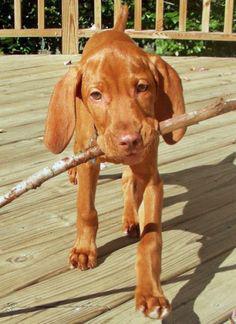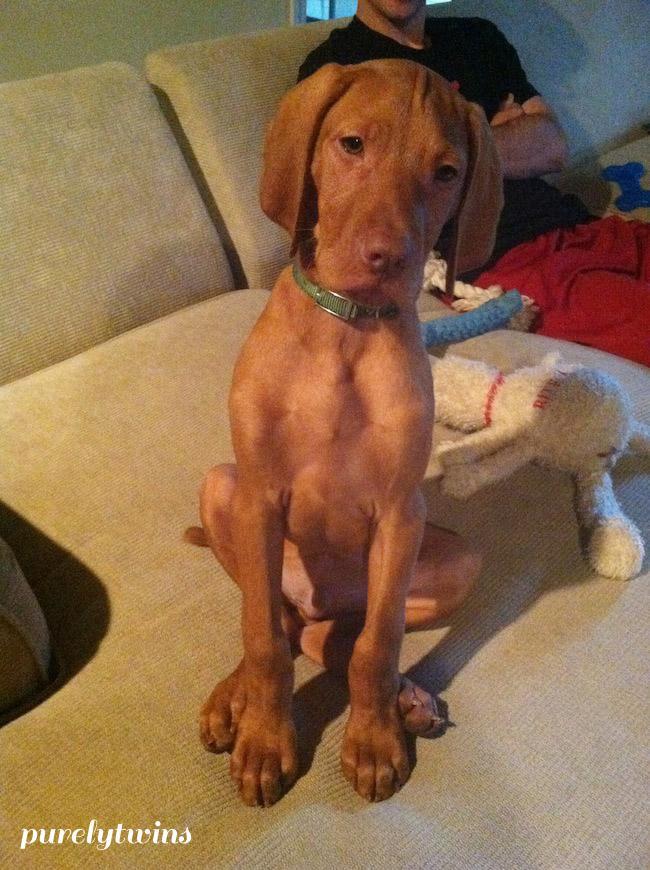The first image is the image on the left, the second image is the image on the right. Assess this claim about the two images: "Left and right images each contain a red-orange dog sitting upright, turned forward, and wearing a collar - but only one of the dogs pictured has a tag on a ring dangling from its collar.". Correct or not? Answer yes or no. No. 